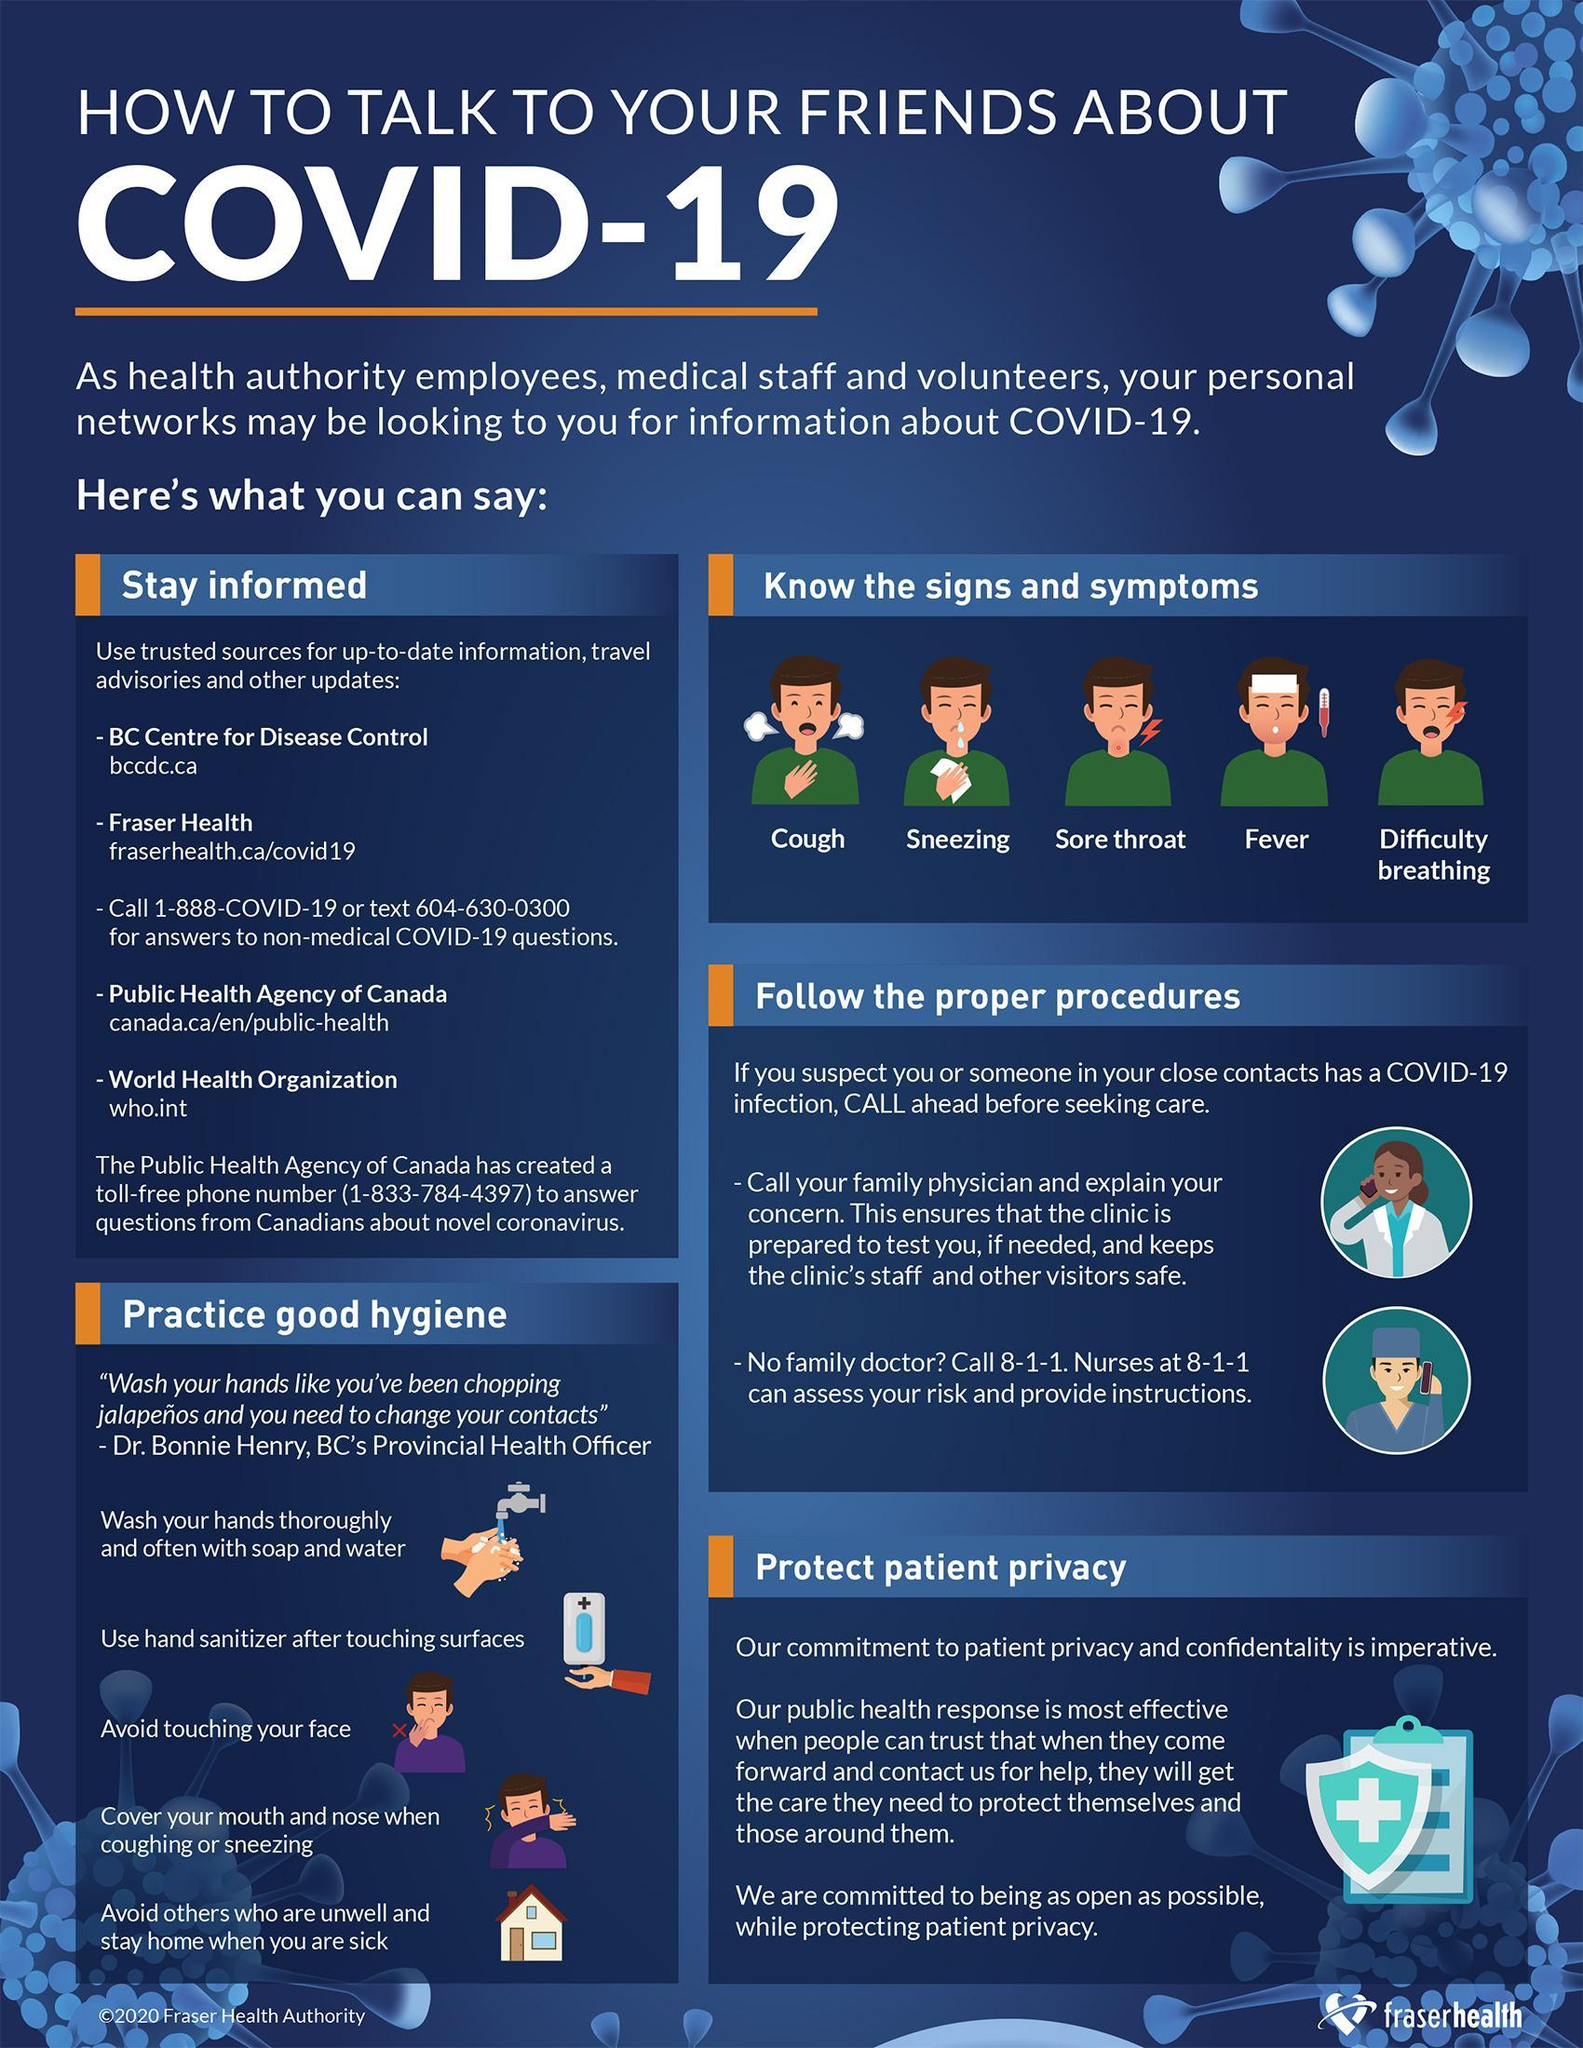What are the symptoms of COVID-19 other than cough, fever & difficulty breathing?
Answer the question with a short phrase. Sneezing, Sore throat 